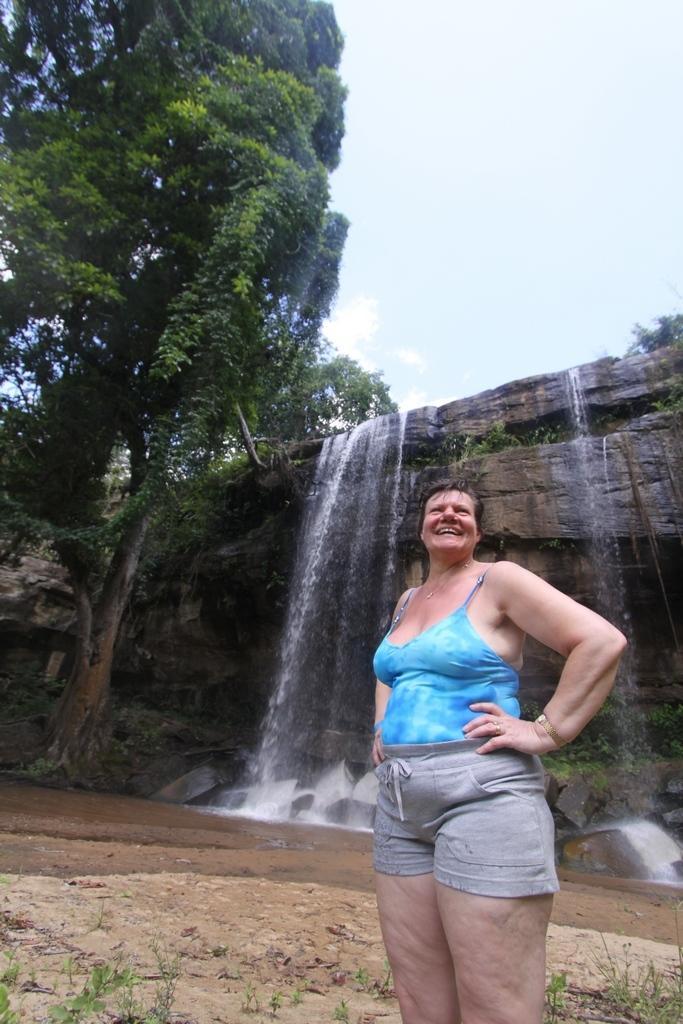How would you summarize this image in a sentence or two? In this picture there is a woman standing, wearing blue color dress and she is smiling. There is some grass on the land. We can observe waterfalls. There are some trees. In the background there is a sky. 